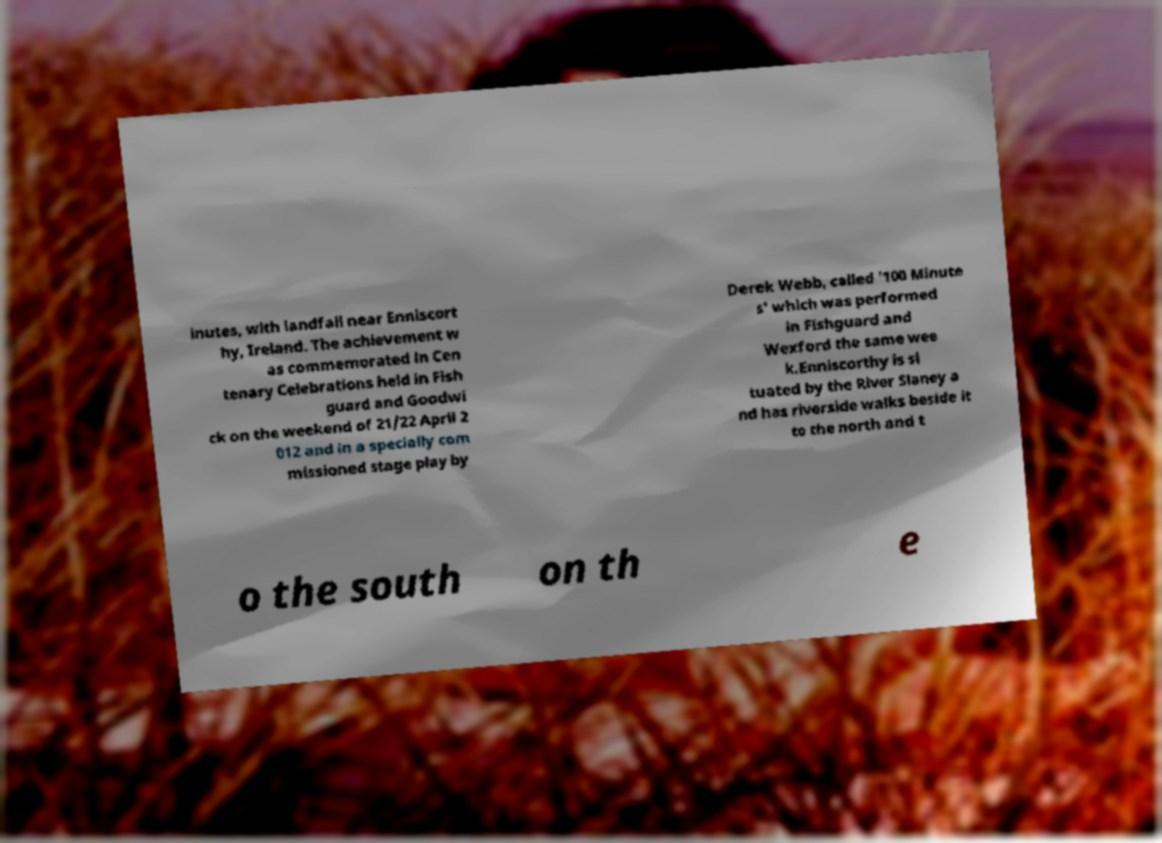There's text embedded in this image that I need extracted. Can you transcribe it verbatim? inutes, with landfall near Enniscort hy, Ireland. The achievement w as commemorated in Cen tenary Celebrations held in Fish guard and Goodwi ck on the weekend of 21/22 April 2 012 and in a specially com missioned stage play by Derek Webb, called '100 Minute s' which was performed in Fishguard and Wexford the same wee k.Enniscorthy is si tuated by the River Slaney a nd has riverside walks beside it to the north and t o the south on th e 